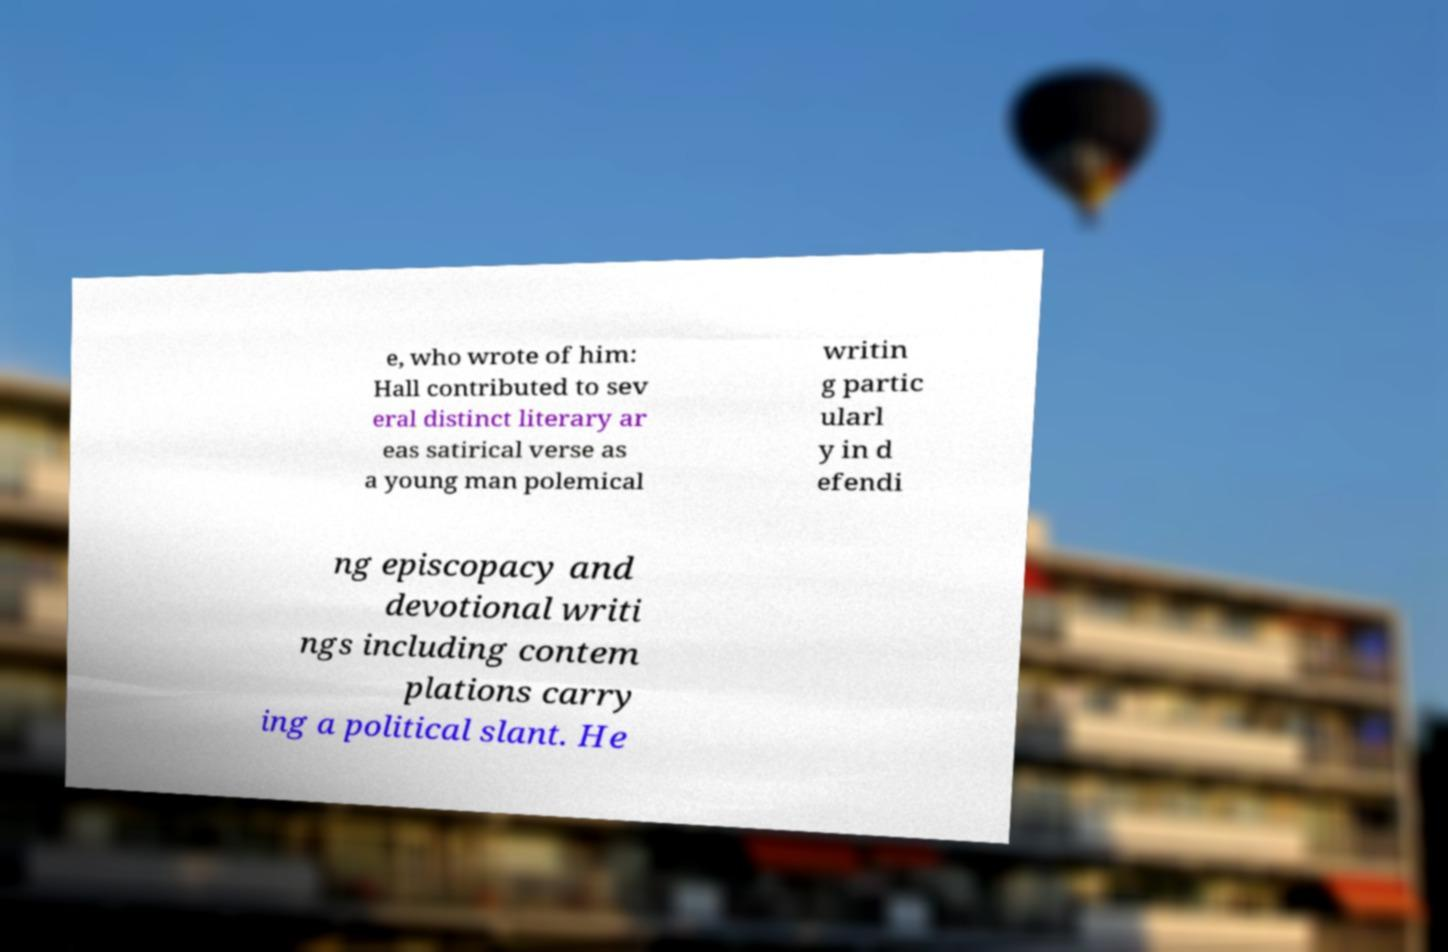Please identify and transcribe the text found in this image. e, who wrote of him: Hall contributed to sev eral distinct literary ar eas satirical verse as a young man polemical writin g partic ularl y in d efendi ng episcopacy and devotional writi ngs including contem plations carry ing a political slant. He 